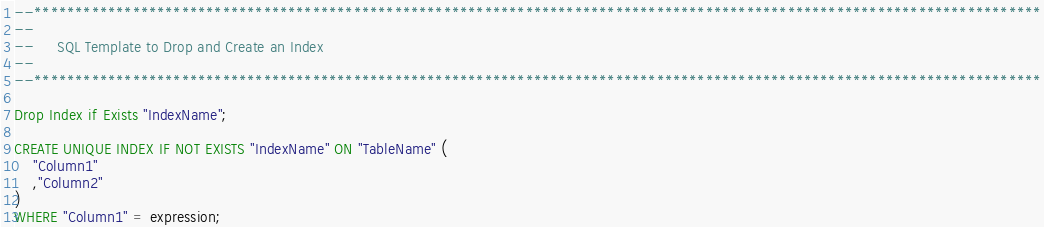Convert code to text. <code><loc_0><loc_0><loc_500><loc_500><_SQL_>--***************************************************************************************************************************
--
--     SQL Template to Drop and Create an Index
--
--***************************************************************************************************************************

Drop Index if Exists "IndexName";

CREATE UNIQUE INDEX IF NOT EXISTS "IndexName" ON "TableName" (
    "Column1"
    ,"Column2"
)
WHERE "Column1" = expression;</code> 